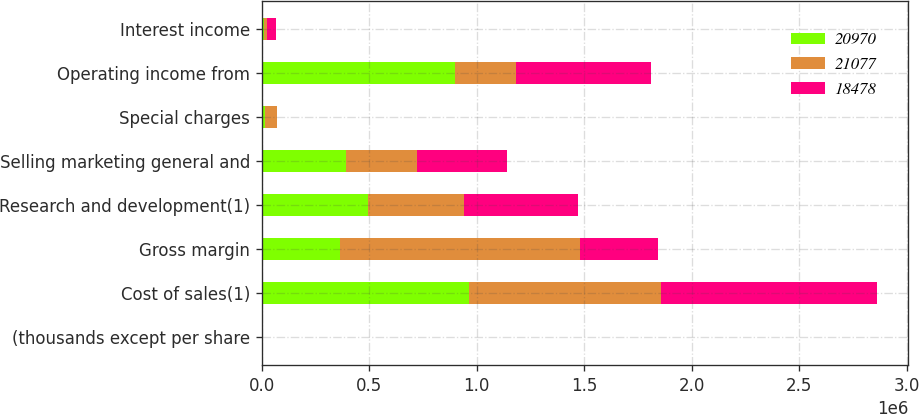<chart> <loc_0><loc_0><loc_500><loc_500><stacked_bar_chart><ecel><fcel>(thousands except per share<fcel>Cost of sales(1)<fcel>Gross margin<fcel>Research and development(1)<fcel>Selling marketing general and<fcel>Special charges<fcel>Operating income from<fcel>Interest income<nl><fcel>20970<fcel>2010<fcel>962081<fcel>361872<fcel>492305<fcel>390560<fcel>16483<fcel>900074<fcel>9837<nl><fcel>21077<fcel>2009<fcel>896271<fcel>1.11864e+06<fcel>446980<fcel>333184<fcel>53656<fcel>284817<fcel>15621<nl><fcel>18478<fcel>2008<fcel>1.00566e+06<fcel>361872<fcel>533480<fcel>415682<fcel>3088<fcel>625025<fcel>41041<nl></chart> 